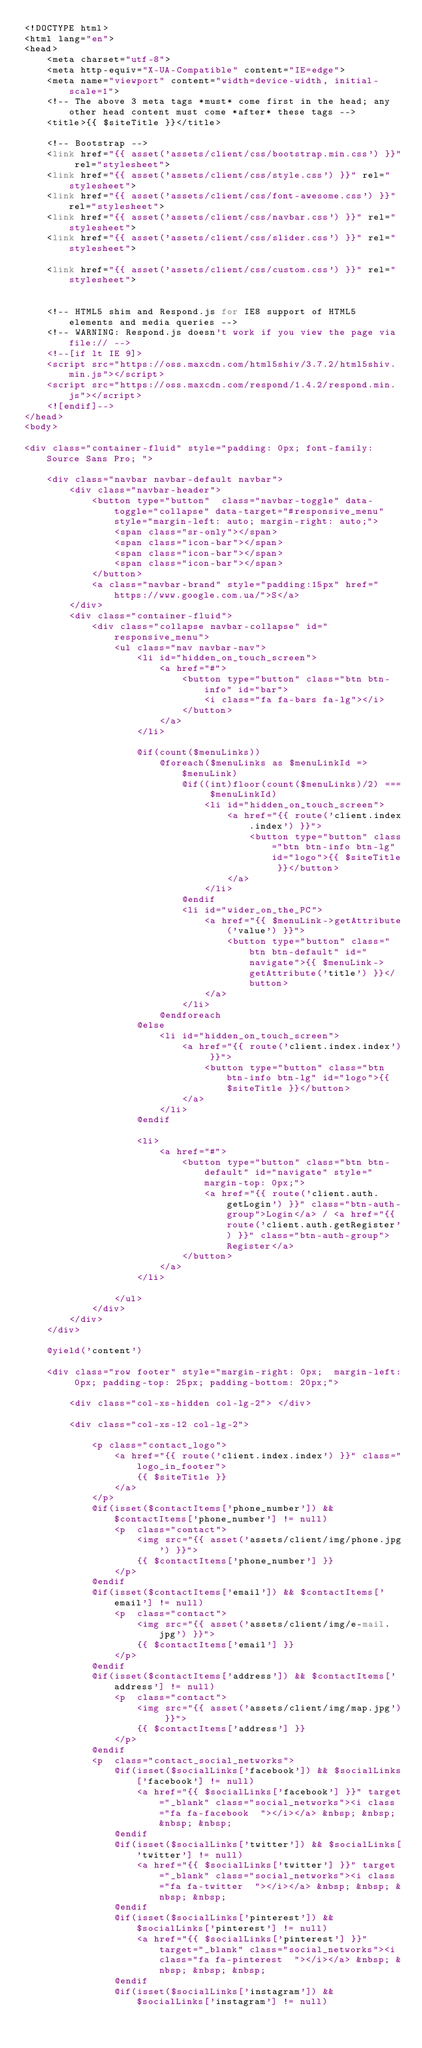<code> <loc_0><loc_0><loc_500><loc_500><_PHP_><!DOCTYPE html>
<html lang="en">
<head>
    <meta charset="utf-8">
    <meta http-equiv="X-UA-Compatible" content="IE=edge">
    <meta name="viewport" content="width=device-width, initial-scale=1">
    <!-- The above 3 meta tags *must* come first in the head; any other head content must come *after* these tags -->
    <title>{{ $siteTitle }}</title>

    <!-- Bootstrap -->
    <link href="{{ asset('assets/client/css/bootstrap.min.css') }}" rel="stylesheet">
    <link href="{{ asset('assets/client/css/style.css') }}" rel="stylesheet">
    <link href="{{ asset('assets/client/css/font-awesome.css') }}" rel="stylesheet">
    <link href="{{ asset('assets/client/css/navbar.css') }}" rel="stylesheet">
    <link href="{{ asset('assets/client/css/slider.css') }}" rel="stylesheet">

    <link href="{{ asset('assets/client/css/custom.css') }}" rel="stylesheet">


    <!-- HTML5 shim and Respond.js for IE8 support of HTML5 elements and media queries -->
    <!-- WARNING: Respond.js doesn't work if you view the page via file:// -->
    <!--[if lt IE 9]>
    <script src="https://oss.maxcdn.com/html5shiv/3.7.2/html5shiv.min.js"></script>
    <script src="https://oss.maxcdn.com/respond/1.4.2/respond.min.js"></script>
    <![endif]-->
</head>
<body>

<div class="container-fluid" style="padding: 0px; font-family: Source Sans Pro; ">

    <div class="navbar navbar-default navbar">
        <div class="navbar-header">
            <button type="button"  class="navbar-toggle" data-toggle="collapse" data-target="#responsive_menu" style="margin-left: auto; margin-right: auto;">
                <span class="sr-only"></span>
                <span class="icon-bar"></span>
                <span class="icon-bar"></span>
                <span class="icon-bar"></span>
            </button>
            <a class="navbar-brand" style="padding:15px" href="https://www.google.com.ua/">S</a>
        </div>
        <div class="container-fluid">
            <div class="collapse navbar-collapse" id="responsive_menu">
                <ul class="nav navbar-nav">
                    <li id="hidden_on_touch_screen">
                        <a href="#">
                            <button type="button" class="btn btn-info" id="bar">
                                <i class="fa fa-bars fa-lg"></i>
                            </button>
                        </a>
                    </li>

                    @if(count($menuLinks))
                        @foreach($menuLinks as $menuLinkId => $menuLink)
                            @if((int)floor(count($menuLinks)/2) === $menuLinkId)
                                <li id="hidden_on_touch_screen">
                                    <a href="{{ route('client.index.index') }}">
                                        <button type="button" class="btn btn-info btn-lg" id="logo">{{ $siteTitle }}</button>
                                    </a>
                                </li>
                            @endif
                            <li id="wider_on_the_PC">
                                <a href="{{ $menuLink->getAttribute('value') }}">
                                    <button type="button" class="btn btn-default" id="navigate">{{ $menuLink->getAttribute('title') }}</button>
                                </a>
                            </li>
                        @endforeach
                    @else
                        <li id="hidden_on_touch_screen">
                            <a href="{{ route('client.index.index') }}">
                                <button type="button" class="btn btn-info btn-lg" id="logo">{{ $siteTitle }}</button>
                            </a>
                        </li>
                    @endif

                    <li>
                        <a href="#">
                            <button type="button" class="btn btn-default" id="navigate" style="margin-top: 0px;">
                                <a href="{{ route('client.auth.getLogin') }}" class="btn-auth-group">Login</a> / <a href="{{ route('client.auth.getRegister') }}" class="btn-auth-group">Register</a>
                            </button>
                        </a>
                    </li>

                </ul>
            </div>
        </div>
    </div>

    @yield('content')

    <div class="row footer" style="margin-right: 0px;  margin-left: 0px; padding-top: 25px; padding-bottom: 20px;">

        <div class="col-xs-hidden col-lg-2"> </div>

        <div class="col-xs-12 col-lg-2">

            <p class="contact_logo">
                <a href="{{ route('client.index.index') }}" class="logo_in_footer">
                    {{ $siteTitle }}
                </a>
            </p>
            @if(isset($contactItems['phone_number']) && $contactItems['phone_number'] != null)
                <p  class="contact">
                    <img src="{{ asset('assets/client/img/phone.jpg') }}">
                    {{ $contactItems['phone_number'] }}
                </p>
            @endif
            @if(isset($contactItems['email']) && $contactItems['email'] != null)
                <p  class="contact">
                    <img src="{{ asset('assets/client/img/e-mail.jpg') }}">
                    {{ $contactItems['email'] }}
                </p>
            @endif
            @if(isset($contactItems['address']) && $contactItems['address'] != null)
                <p  class="contact">
                    <img src="{{ asset('assets/client/img/map.jpg') }}">
                    {{ $contactItems['address'] }}
                </p>
            @endif
            <p  class="contact_social_networks">
                @if(isset($socialLinks['facebook']) && $socialLinks['facebook'] != null)
                    <a href="{{ $socialLinks['facebook'] }}" target="_blank" class="social_networks"><i class="fa fa-facebook  "></i></a> &nbsp; &nbsp; &nbsp; &nbsp;
                @endif
                @if(isset($socialLinks['twitter']) && $socialLinks['twitter'] != null)
                    <a href="{{ $socialLinks['twitter'] }}" target="_blank" class="social_networks"><i class="fa fa-twitter  "></i></a> &nbsp; &nbsp; &nbsp; &nbsp;
                @endif
                @if(isset($socialLinks['pinterest']) && $socialLinks['pinterest'] != null)
                    <a href="{{ $socialLinks['pinterest'] }}" target="_blank" class="social_networks"><i class="fa fa-pinterest  "></i></a> &nbsp; &nbsp; &nbsp; &nbsp;
                @endif
                @if(isset($socialLinks['instagram']) && $socialLinks['instagram'] != null)</code> 